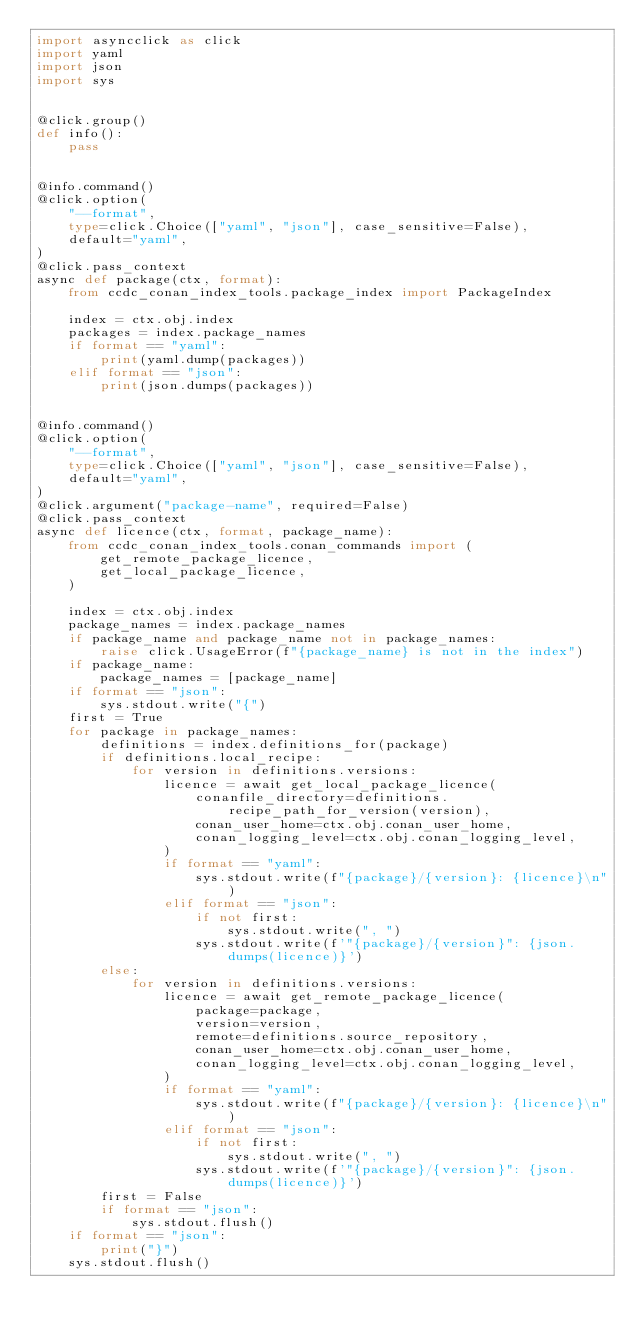<code> <loc_0><loc_0><loc_500><loc_500><_Python_>import asyncclick as click
import yaml
import json
import sys


@click.group()
def info():
    pass


@info.command()
@click.option(
    "--format",
    type=click.Choice(["yaml", "json"], case_sensitive=False),
    default="yaml",
)
@click.pass_context
async def package(ctx, format):
    from ccdc_conan_index_tools.package_index import PackageIndex

    index = ctx.obj.index
    packages = index.package_names
    if format == "yaml":
        print(yaml.dump(packages))
    elif format == "json":
        print(json.dumps(packages))


@info.command()
@click.option(
    "--format",
    type=click.Choice(["yaml", "json"], case_sensitive=False),
    default="yaml",
)
@click.argument("package-name", required=False)
@click.pass_context
async def licence(ctx, format, package_name):
    from ccdc_conan_index_tools.conan_commands import (
        get_remote_package_licence,
        get_local_package_licence,
    )

    index = ctx.obj.index
    package_names = index.package_names
    if package_name and package_name not in package_names:
        raise click.UsageError(f"{package_name} is not in the index")
    if package_name:
        package_names = [package_name]
    if format == "json":
        sys.stdout.write("{")
    first = True
    for package in package_names:
        definitions = index.definitions_for(package)
        if definitions.local_recipe:
            for version in definitions.versions:
                licence = await get_local_package_licence(
                    conanfile_directory=definitions.recipe_path_for_version(version),
                    conan_user_home=ctx.obj.conan_user_home,
                    conan_logging_level=ctx.obj.conan_logging_level,
                )
                if format == "yaml":
                    sys.stdout.write(f"{package}/{version}: {licence}\n")
                elif format == "json":
                    if not first:
                        sys.stdout.write(", ")
                    sys.stdout.write(f'"{package}/{version}": {json.dumps(licence)}')
        else:
            for version in definitions.versions:
                licence = await get_remote_package_licence(
                    package=package,
                    version=version,
                    remote=definitions.source_repository,
                    conan_user_home=ctx.obj.conan_user_home,
                    conan_logging_level=ctx.obj.conan_logging_level,
                )
                if format == "yaml":
                    sys.stdout.write(f"{package}/{version}: {licence}\n")
                elif format == "json":
                    if not first:
                        sys.stdout.write(", ")
                    sys.stdout.write(f'"{package}/{version}": {json.dumps(licence)}')
        first = False
        if format == "json":
            sys.stdout.flush()
    if format == "json":
        print("}")
    sys.stdout.flush()
</code> 